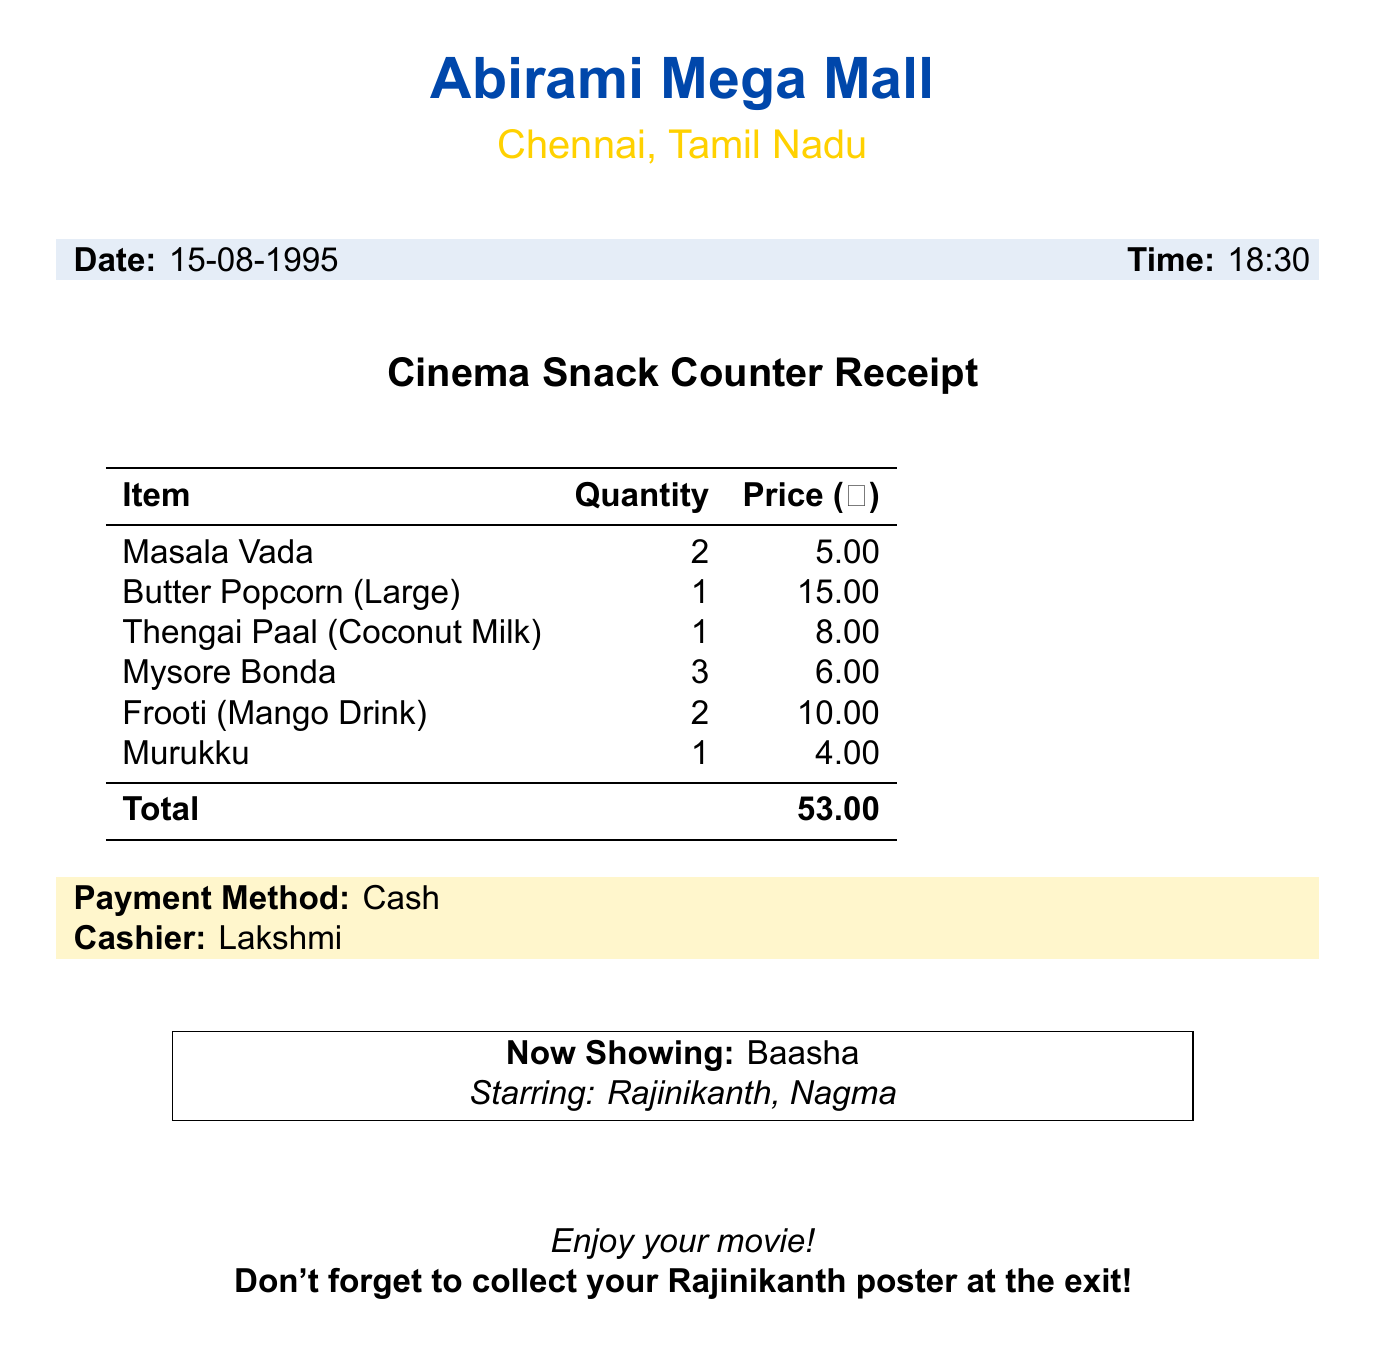What is the theater name? The theater name is listed at the top of the document.
Answer: Abirami Mega Mall What snack item cost 15.00? The document lists all items with their prices, and the one that costs 15.00 can be identified.
Answer: Butter Popcorn (Large) How many items were purchased in total? The total number of items purchased can be calculated by summing the quantities listed for each item.
Answer: 9 What was the payment method? The payment method is explicitly stated in the receipt.
Answer: Cash How much was the Thengai Paal? The price of Thengai Paal is mentioned in the list of items.
Answer: 8.00 Who was the cashier? The cashier's name is provided in the receipt details.
Answer: Lakshmi Which movie was playing at the time of purchase? The title of the movie currently showing is specified in the document.
Answer: Baasha What is the total amount spent? The total amount at the bottom of the receipt indicates the overall expenditure.
Answer: 53.00 How many Mysore Bonda were bought? The quantity of Mysore Bonda is explicitly stated next to the item in the document.
Answer: 3 